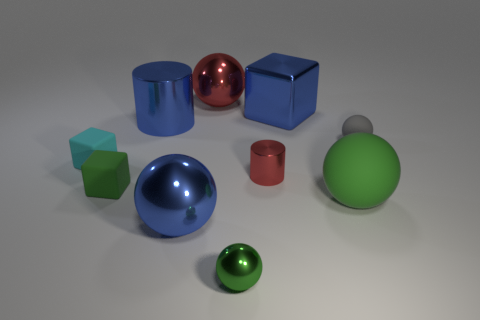Subtract 2 spheres. How many spheres are left? 3 Subtract all red spheres. How many spheres are left? 4 Subtract all gray spheres. How many spheres are left? 4 Subtract all gray balls. Subtract all purple cylinders. How many balls are left? 4 Subtract all cylinders. How many objects are left? 8 Subtract 0 brown spheres. How many objects are left? 10 Subtract all large green rubber spheres. Subtract all cyan objects. How many objects are left? 8 Add 7 tiny cyan rubber things. How many tiny cyan rubber things are left? 8 Add 5 large yellow balls. How many large yellow balls exist? 5 